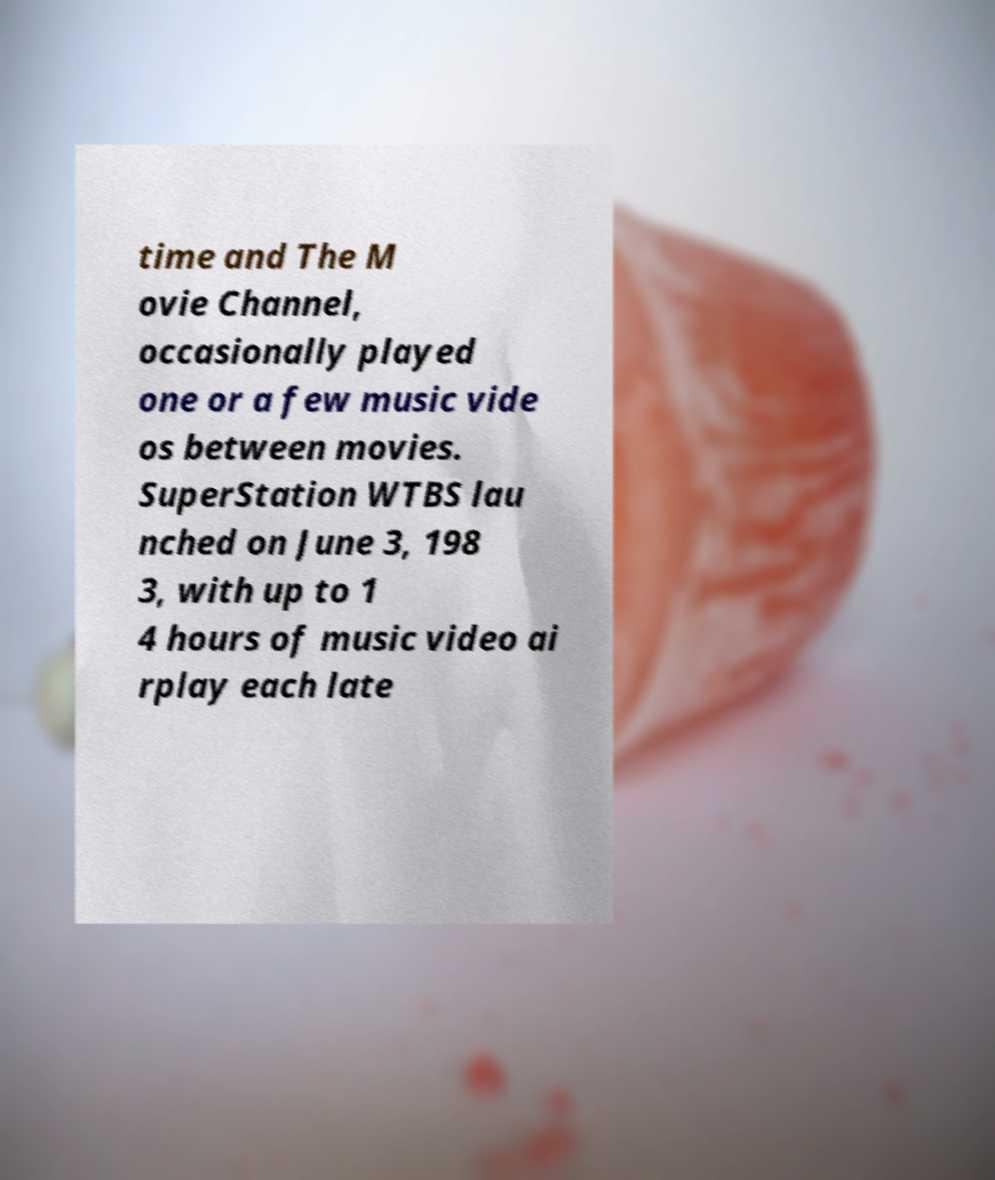Can you read and provide the text displayed in the image?This photo seems to have some interesting text. Can you extract and type it out for me? time and The M ovie Channel, occasionally played one or a few music vide os between movies. SuperStation WTBS lau nched on June 3, 198 3, with up to 1 4 hours of music video ai rplay each late 